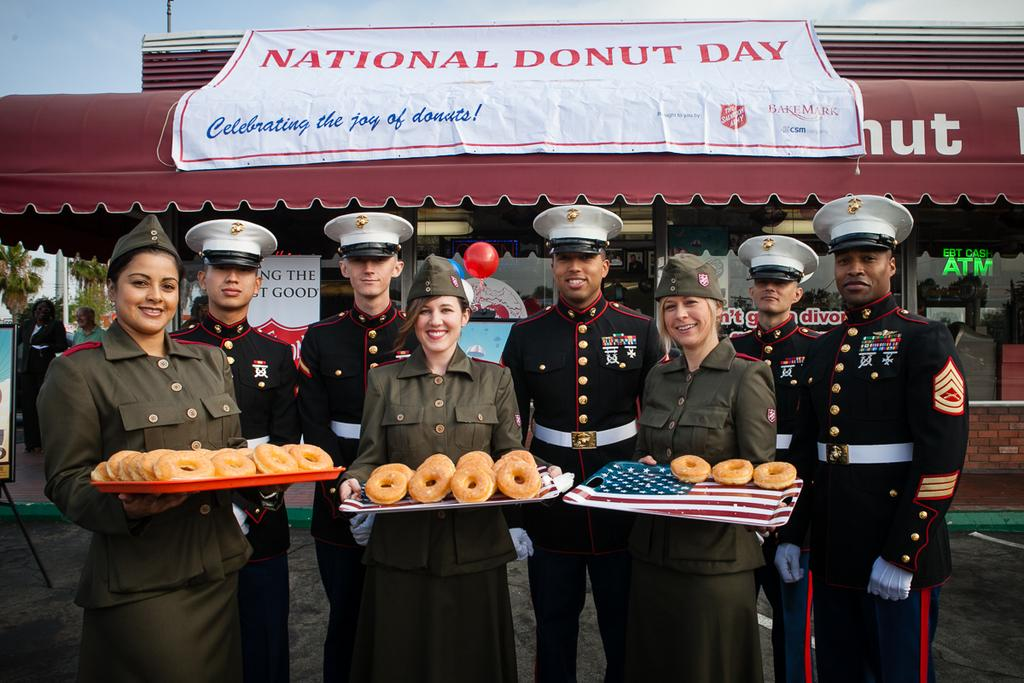How many ladies are present in the image? There are three ladies standing in the image. What are the ladies holding in the image? The ladies are holding an object with donuts on it. Can you describe the people standing behind the ladies? There are five persons standing behind the ladies. What can be seen in the background of the image? There is a store in the background of the image. What type of appliance is being used by the ladies in the image? There is no appliance visible in the image; the ladies are holding an object with donuts on it. What is the condition of the hose in the image? There is no hose present in the image. 